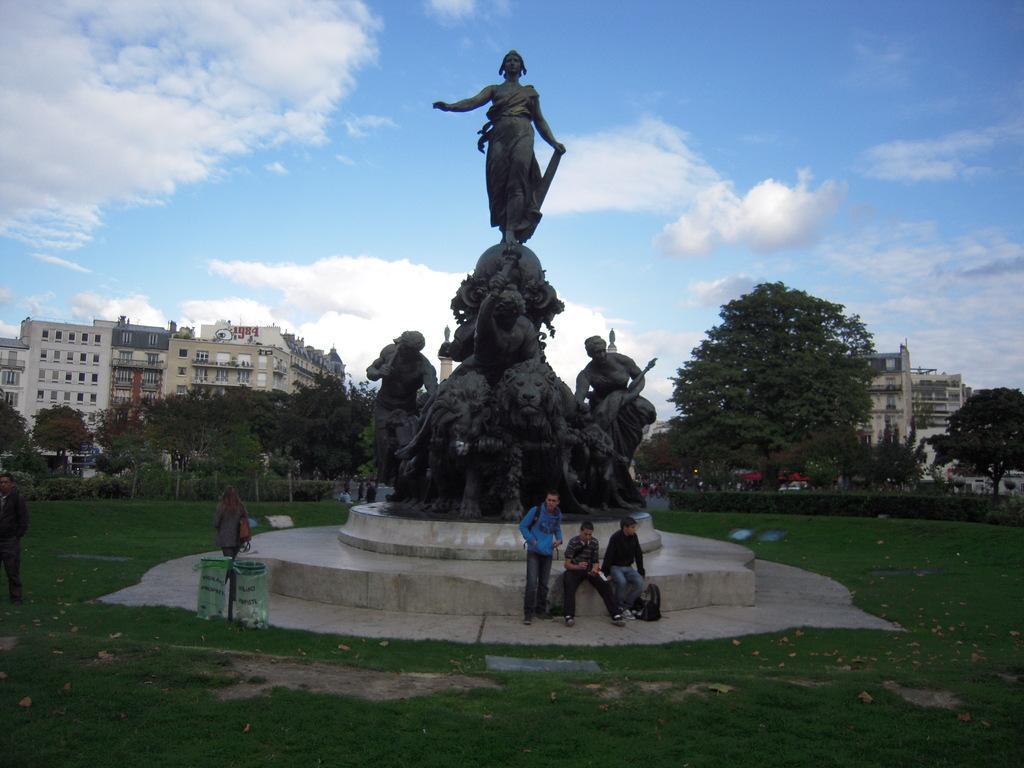Describe this image in one or two sentences. As we can see in the image there are statues, few people, plants, trees and buildings. There is grass. At the top there is sky and there are clouds. 